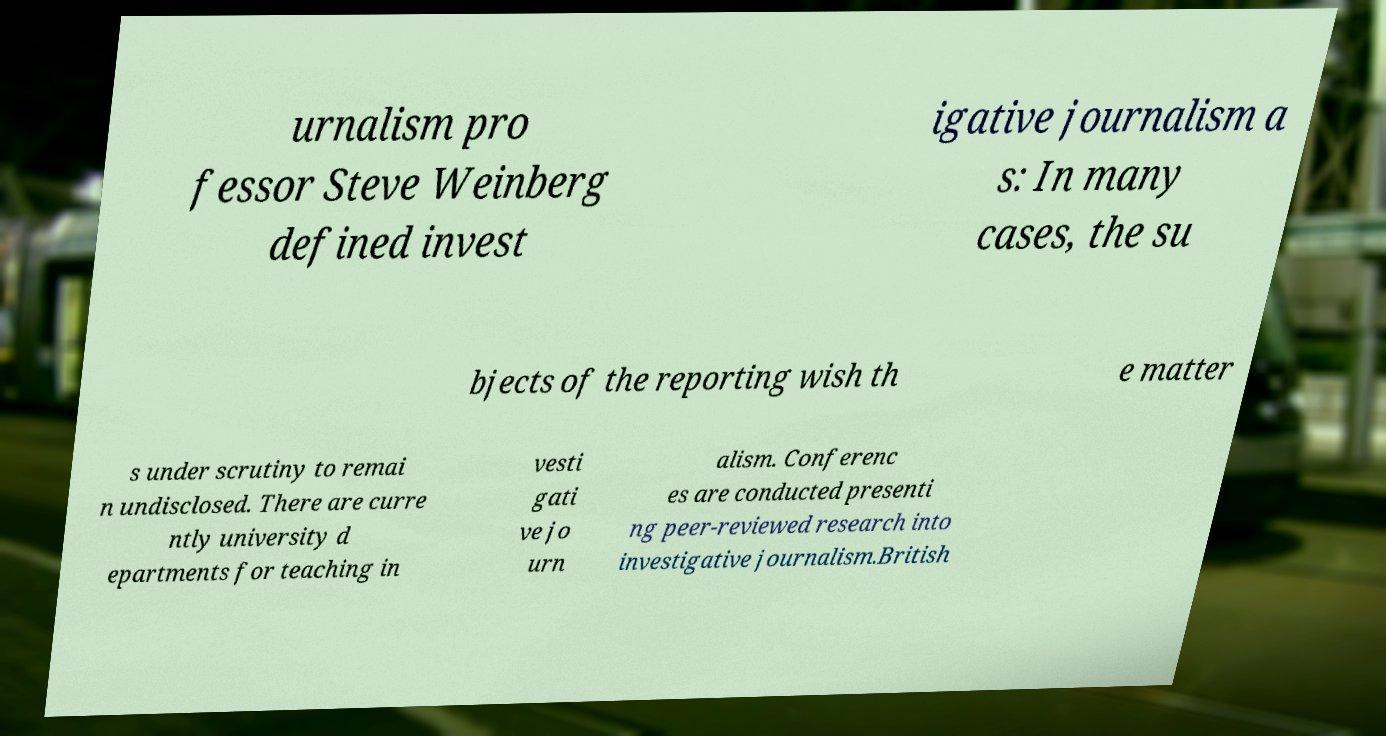There's text embedded in this image that I need extracted. Can you transcribe it verbatim? urnalism pro fessor Steve Weinberg defined invest igative journalism a s: In many cases, the su bjects of the reporting wish th e matter s under scrutiny to remai n undisclosed. There are curre ntly university d epartments for teaching in vesti gati ve jo urn alism. Conferenc es are conducted presenti ng peer-reviewed research into investigative journalism.British 